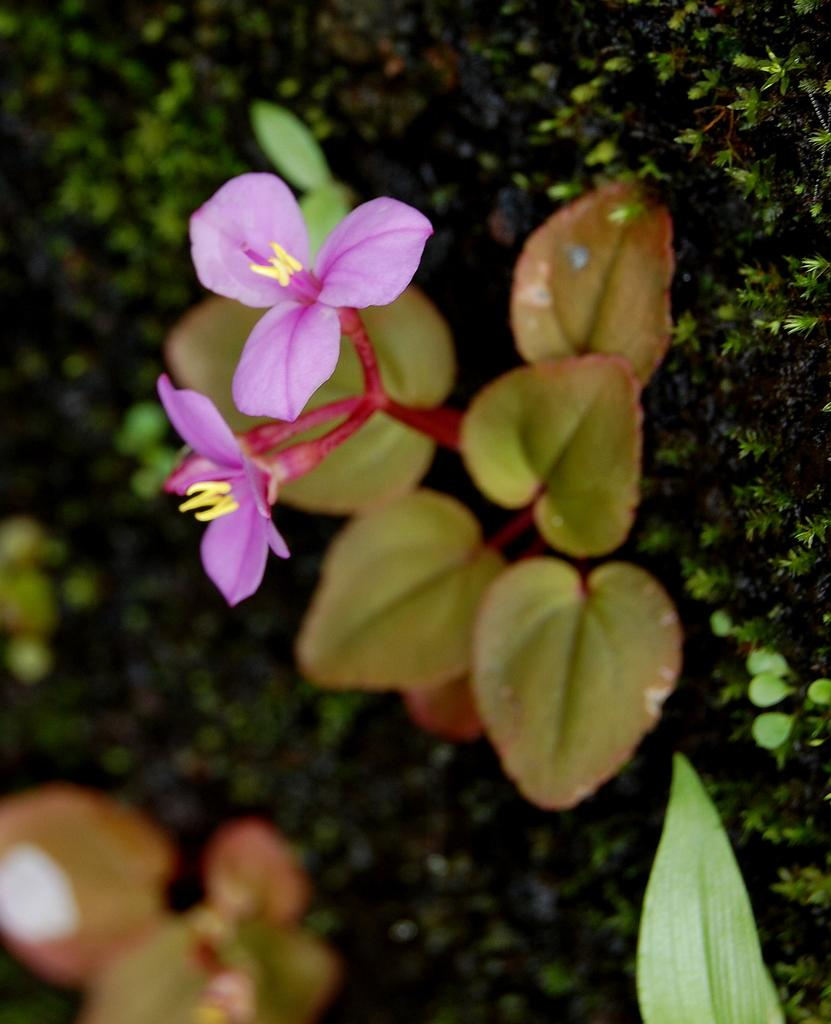What type of plants can be seen in the image? There are flowers and leaves in the image. Can you describe the background of the image? The background of the image is blurry. What type of hobbies do the houses in the image enjoy? There are no houses present in the image, so it is not possible to determine what hobbies they might enjoy. 